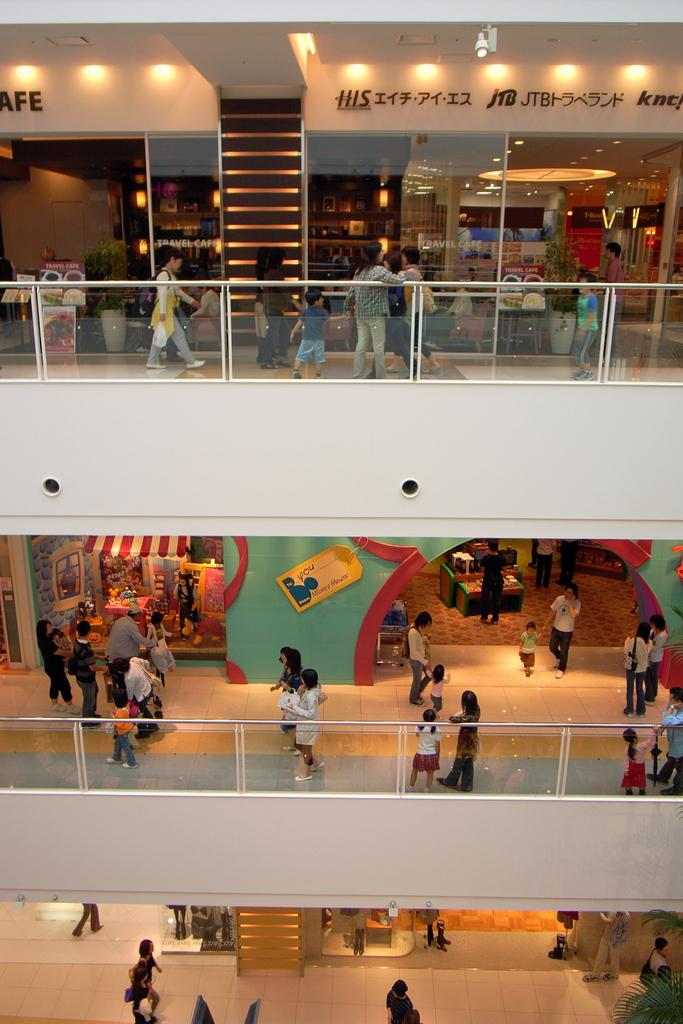What type of structure is visible in the image? There is a building with railings in the image. How many people can be seen in the image? There are many people in the image. What architectural feature is present in the image? There are steps in the image. What signage is visible in the image? There are name boards in the image. What type of illumination is present in the image? There are lights in the image. Who is the owner of the planes in the image? There are no planes present in the image, so it is not possible to determine the owner. 